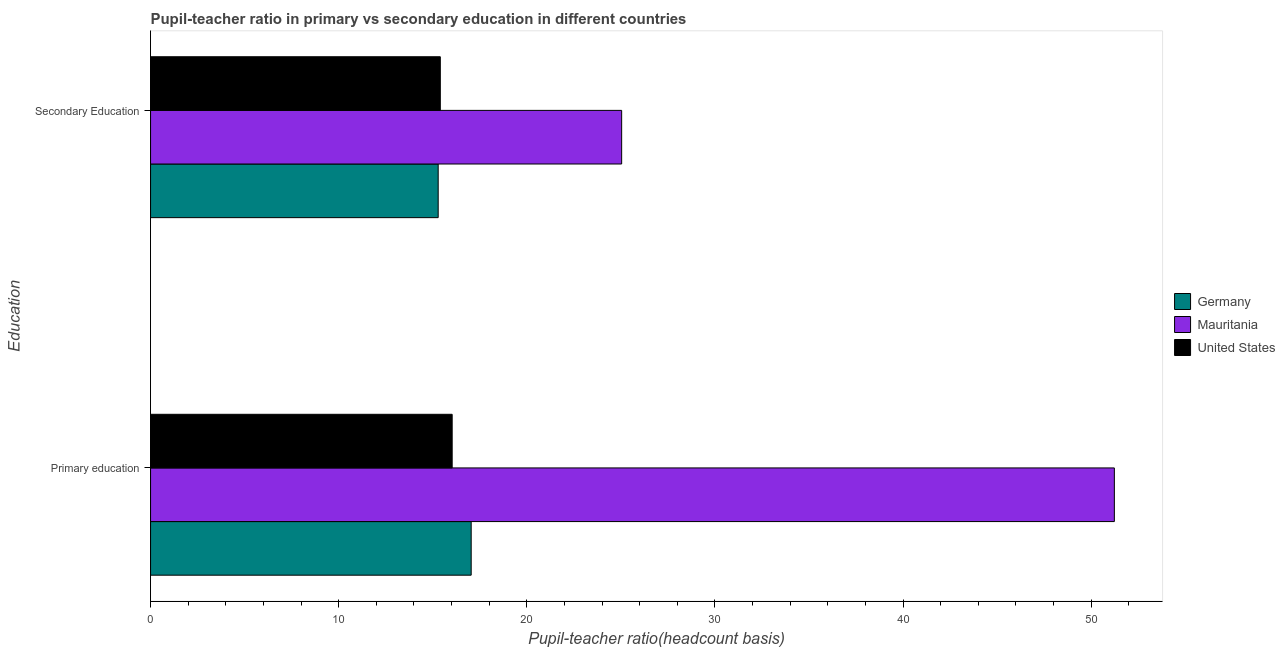How many groups of bars are there?
Provide a succinct answer. 2. Are the number of bars per tick equal to the number of legend labels?
Provide a succinct answer. Yes. How many bars are there on the 1st tick from the top?
Keep it short and to the point. 3. What is the label of the 1st group of bars from the top?
Keep it short and to the point. Secondary Education. What is the pupil teacher ratio on secondary education in United States?
Your response must be concise. 15.4. Across all countries, what is the maximum pupil-teacher ratio in primary education?
Provide a short and direct response. 51.24. Across all countries, what is the minimum pupil-teacher ratio in primary education?
Offer a very short reply. 16.03. In which country was the pupil teacher ratio on secondary education maximum?
Offer a terse response. Mauritania. What is the total pupil teacher ratio on secondary education in the graph?
Offer a very short reply. 55.74. What is the difference between the pupil-teacher ratio in primary education in United States and that in Mauritania?
Keep it short and to the point. -35.2. What is the difference between the pupil teacher ratio on secondary education in Germany and the pupil-teacher ratio in primary education in United States?
Your answer should be compact. -0.74. What is the average pupil-teacher ratio in primary education per country?
Your response must be concise. 28.1. What is the difference between the pupil-teacher ratio in primary education and pupil teacher ratio on secondary education in United States?
Your answer should be compact. 0.63. In how many countries, is the pupil-teacher ratio in primary education greater than 4 ?
Your response must be concise. 3. What is the ratio of the pupil-teacher ratio in primary education in Mauritania to that in United States?
Offer a terse response. 3.2. Is the pupil-teacher ratio in primary education in Germany less than that in United States?
Offer a very short reply. No. What does the 1st bar from the top in Primary education represents?
Provide a short and direct response. United States. What does the 3rd bar from the bottom in Primary education represents?
Keep it short and to the point. United States. Does the graph contain grids?
Your answer should be very brief. No. How many legend labels are there?
Ensure brevity in your answer.  3. What is the title of the graph?
Give a very brief answer. Pupil-teacher ratio in primary vs secondary education in different countries. Does "Cayman Islands" appear as one of the legend labels in the graph?
Your answer should be compact. No. What is the label or title of the X-axis?
Your answer should be very brief. Pupil-teacher ratio(headcount basis). What is the label or title of the Y-axis?
Provide a short and direct response. Education. What is the Pupil-teacher ratio(headcount basis) of Germany in Primary education?
Your answer should be compact. 17.04. What is the Pupil-teacher ratio(headcount basis) of Mauritania in Primary education?
Your answer should be compact. 51.24. What is the Pupil-teacher ratio(headcount basis) in United States in Primary education?
Offer a very short reply. 16.03. What is the Pupil-teacher ratio(headcount basis) in Germany in Secondary Education?
Provide a short and direct response. 15.29. What is the Pupil-teacher ratio(headcount basis) in Mauritania in Secondary Education?
Your answer should be compact. 25.04. What is the Pupil-teacher ratio(headcount basis) of United States in Secondary Education?
Provide a short and direct response. 15.4. Across all Education, what is the maximum Pupil-teacher ratio(headcount basis) in Germany?
Your answer should be compact. 17.04. Across all Education, what is the maximum Pupil-teacher ratio(headcount basis) in Mauritania?
Give a very brief answer. 51.24. Across all Education, what is the maximum Pupil-teacher ratio(headcount basis) of United States?
Your answer should be compact. 16.03. Across all Education, what is the minimum Pupil-teacher ratio(headcount basis) of Germany?
Offer a very short reply. 15.29. Across all Education, what is the minimum Pupil-teacher ratio(headcount basis) in Mauritania?
Provide a short and direct response. 25.04. Across all Education, what is the minimum Pupil-teacher ratio(headcount basis) of United States?
Your response must be concise. 15.4. What is the total Pupil-teacher ratio(headcount basis) of Germany in the graph?
Provide a succinct answer. 32.33. What is the total Pupil-teacher ratio(headcount basis) in Mauritania in the graph?
Offer a terse response. 76.28. What is the total Pupil-teacher ratio(headcount basis) in United States in the graph?
Your answer should be compact. 31.44. What is the difference between the Pupil-teacher ratio(headcount basis) in Germany in Primary education and that in Secondary Education?
Your answer should be very brief. 1.75. What is the difference between the Pupil-teacher ratio(headcount basis) in Mauritania in Primary education and that in Secondary Education?
Your answer should be very brief. 26.19. What is the difference between the Pupil-teacher ratio(headcount basis) of United States in Primary education and that in Secondary Education?
Your response must be concise. 0.63. What is the difference between the Pupil-teacher ratio(headcount basis) in Germany in Primary education and the Pupil-teacher ratio(headcount basis) in Mauritania in Secondary Education?
Your response must be concise. -8. What is the difference between the Pupil-teacher ratio(headcount basis) of Germany in Primary education and the Pupil-teacher ratio(headcount basis) of United States in Secondary Education?
Provide a succinct answer. 1.64. What is the difference between the Pupil-teacher ratio(headcount basis) of Mauritania in Primary education and the Pupil-teacher ratio(headcount basis) of United States in Secondary Education?
Offer a terse response. 35.83. What is the average Pupil-teacher ratio(headcount basis) of Germany per Education?
Offer a terse response. 16.17. What is the average Pupil-teacher ratio(headcount basis) in Mauritania per Education?
Your answer should be very brief. 38.14. What is the average Pupil-teacher ratio(headcount basis) of United States per Education?
Offer a very short reply. 15.72. What is the difference between the Pupil-teacher ratio(headcount basis) in Germany and Pupil-teacher ratio(headcount basis) in Mauritania in Primary education?
Give a very brief answer. -34.19. What is the difference between the Pupil-teacher ratio(headcount basis) in Germany and Pupil-teacher ratio(headcount basis) in United States in Primary education?
Offer a terse response. 1.01. What is the difference between the Pupil-teacher ratio(headcount basis) of Mauritania and Pupil-teacher ratio(headcount basis) of United States in Primary education?
Provide a succinct answer. 35.2. What is the difference between the Pupil-teacher ratio(headcount basis) in Germany and Pupil-teacher ratio(headcount basis) in Mauritania in Secondary Education?
Your answer should be very brief. -9.75. What is the difference between the Pupil-teacher ratio(headcount basis) of Germany and Pupil-teacher ratio(headcount basis) of United States in Secondary Education?
Give a very brief answer. -0.11. What is the difference between the Pupil-teacher ratio(headcount basis) in Mauritania and Pupil-teacher ratio(headcount basis) in United States in Secondary Education?
Offer a terse response. 9.64. What is the ratio of the Pupil-teacher ratio(headcount basis) in Germany in Primary education to that in Secondary Education?
Offer a terse response. 1.11. What is the ratio of the Pupil-teacher ratio(headcount basis) in Mauritania in Primary education to that in Secondary Education?
Keep it short and to the point. 2.05. What is the ratio of the Pupil-teacher ratio(headcount basis) in United States in Primary education to that in Secondary Education?
Provide a short and direct response. 1.04. What is the difference between the highest and the second highest Pupil-teacher ratio(headcount basis) in Germany?
Your answer should be very brief. 1.75. What is the difference between the highest and the second highest Pupil-teacher ratio(headcount basis) in Mauritania?
Ensure brevity in your answer.  26.19. What is the difference between the highest and the second highest Pupil-teacher ratio(headcount basis) in United States?
Your answer should be compact. 0.63. What is the difference between the highest and the lowest Pupil-teacher ratio(headcount basis) of Germany?
Keep it short and to the point. 1.75. What is the difference between the highest and the lowest Pupil-teacher ratio(headcount basis) of Mauritania?
Ensure brevity in your answer.  26.19. What is the difference between the highest and the lowest Pupil-teacher ratio(headcount basis) of United States?
Ensure brevity in your answer.  0.63. 